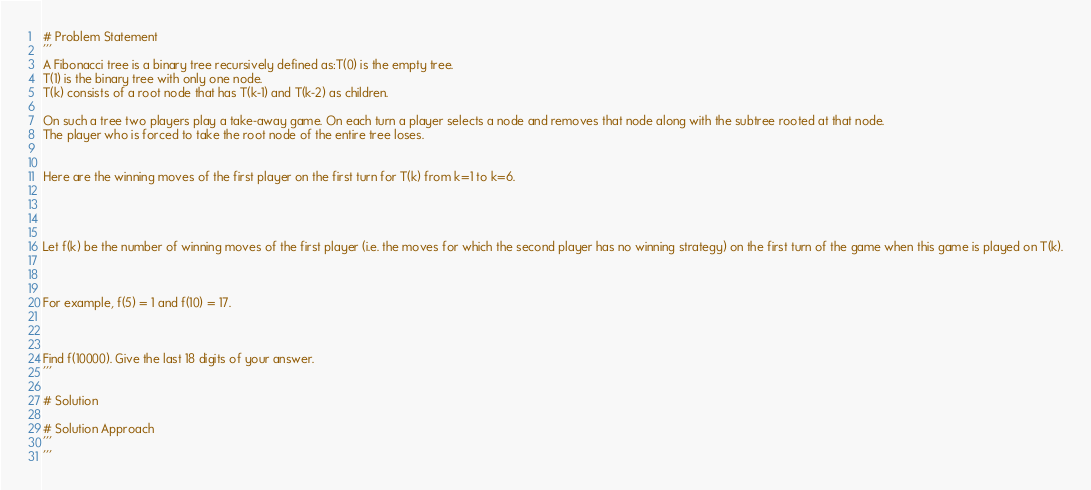Convert code to text. <code><loc_0><loc_0><loc_500><loc_500><_Python_>
# Problem Statement 
'''
A Fibonacci tree is a binary tree recursively defined as:T(0) is the empty tree.
T(1) is the binary tree with only one node.
T(k) consists of a root node that has T(k-1) and T(k-2) as children.

On such a tree two players play a take-away game. On each turn a player selects a node and removes that node along with the subtree rooted at that node.
The player who is forced to take the root node of the entire tree loses.


Here are the winning moves of the first player on the first turn for T(k) from k=1 to k=6.




Let f(k) be the number of winning moves of the first player (i.e. the moves for which the second player has no winning strategy) on the first turn of the game when this game is played on T(k).



For example, f(5) = 1 and f(10) = 17.



Find f(10000). Give the last 18 digits of your answer.
'''

# Solution 

# Solution Approach 
'''
'''
</code> 